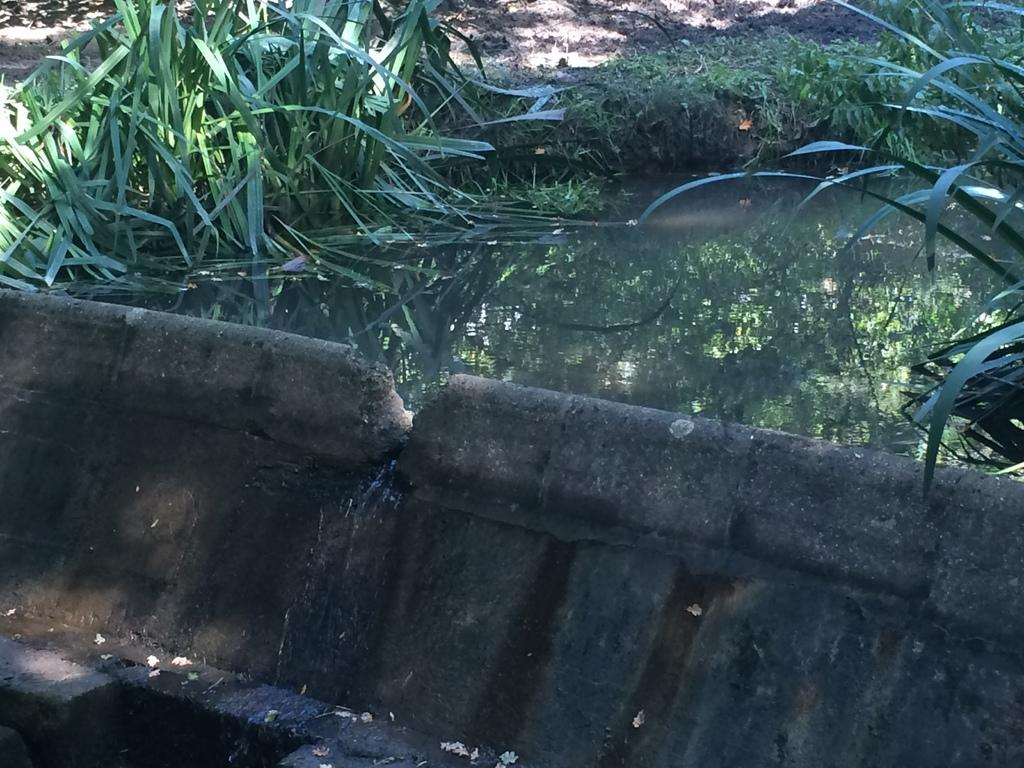What type of body of water is present in the image? There is a pond in the image. What is located in front of the pond? There is cement fencing in front of the pond. What type of vegetation can be seen on both sides of the image? There is grass on the left side and the right side of the image. How many umbrellas are being used by the fish in the pond? There are no umbrellas present in the image, and fish are not using any umbrellas. 